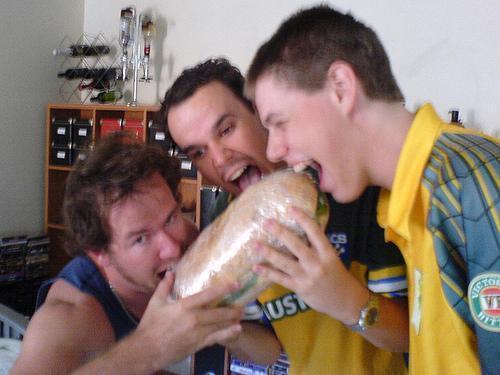How many people can be seen?
Give a very brief answer. 3. 